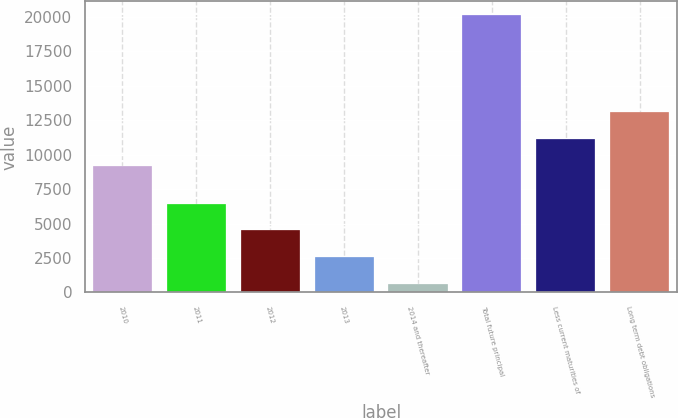Convert chart to OTSL. <chart><loc_0><loc_0><loc_500><loc_500><bar_chart><fcel>2010<fcel>2011<fcel>2012<fcel>2013<fcel>2014 and thereafter<fcel>Total future principal<fcel>Less current maturities of<fcel>Long term debt obligations<nl><fcel>9178<fcel>6452.2<fcel>4498.8<fcel>2545.4<fcel>592<fcel>20126<fcel>11131.4<fcel>13084.8<nl></chart> 